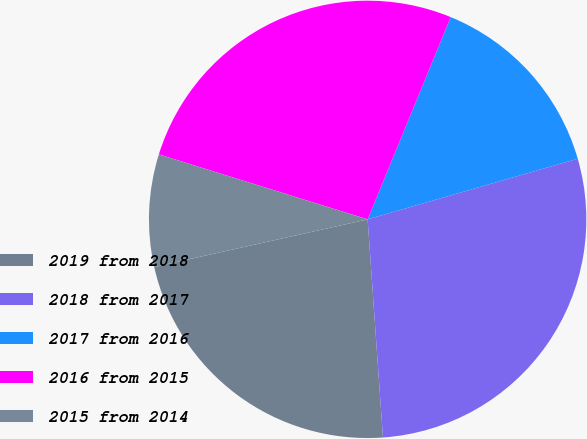Convert chart to OTSL. <chart><loc_0><loc_0><loc_500><loc_500><pie_chart><fcel>2019 from 2018<fcel>2018 from 2017<fcel>2017 from 2016<fcel>2016 from 2015<fcel>2015 from 2014<nl><fcel>22.62%<fcel>28.36%<fcel>14.33%<fcel>26.4%<fcel>8.3%<nl></chart> 